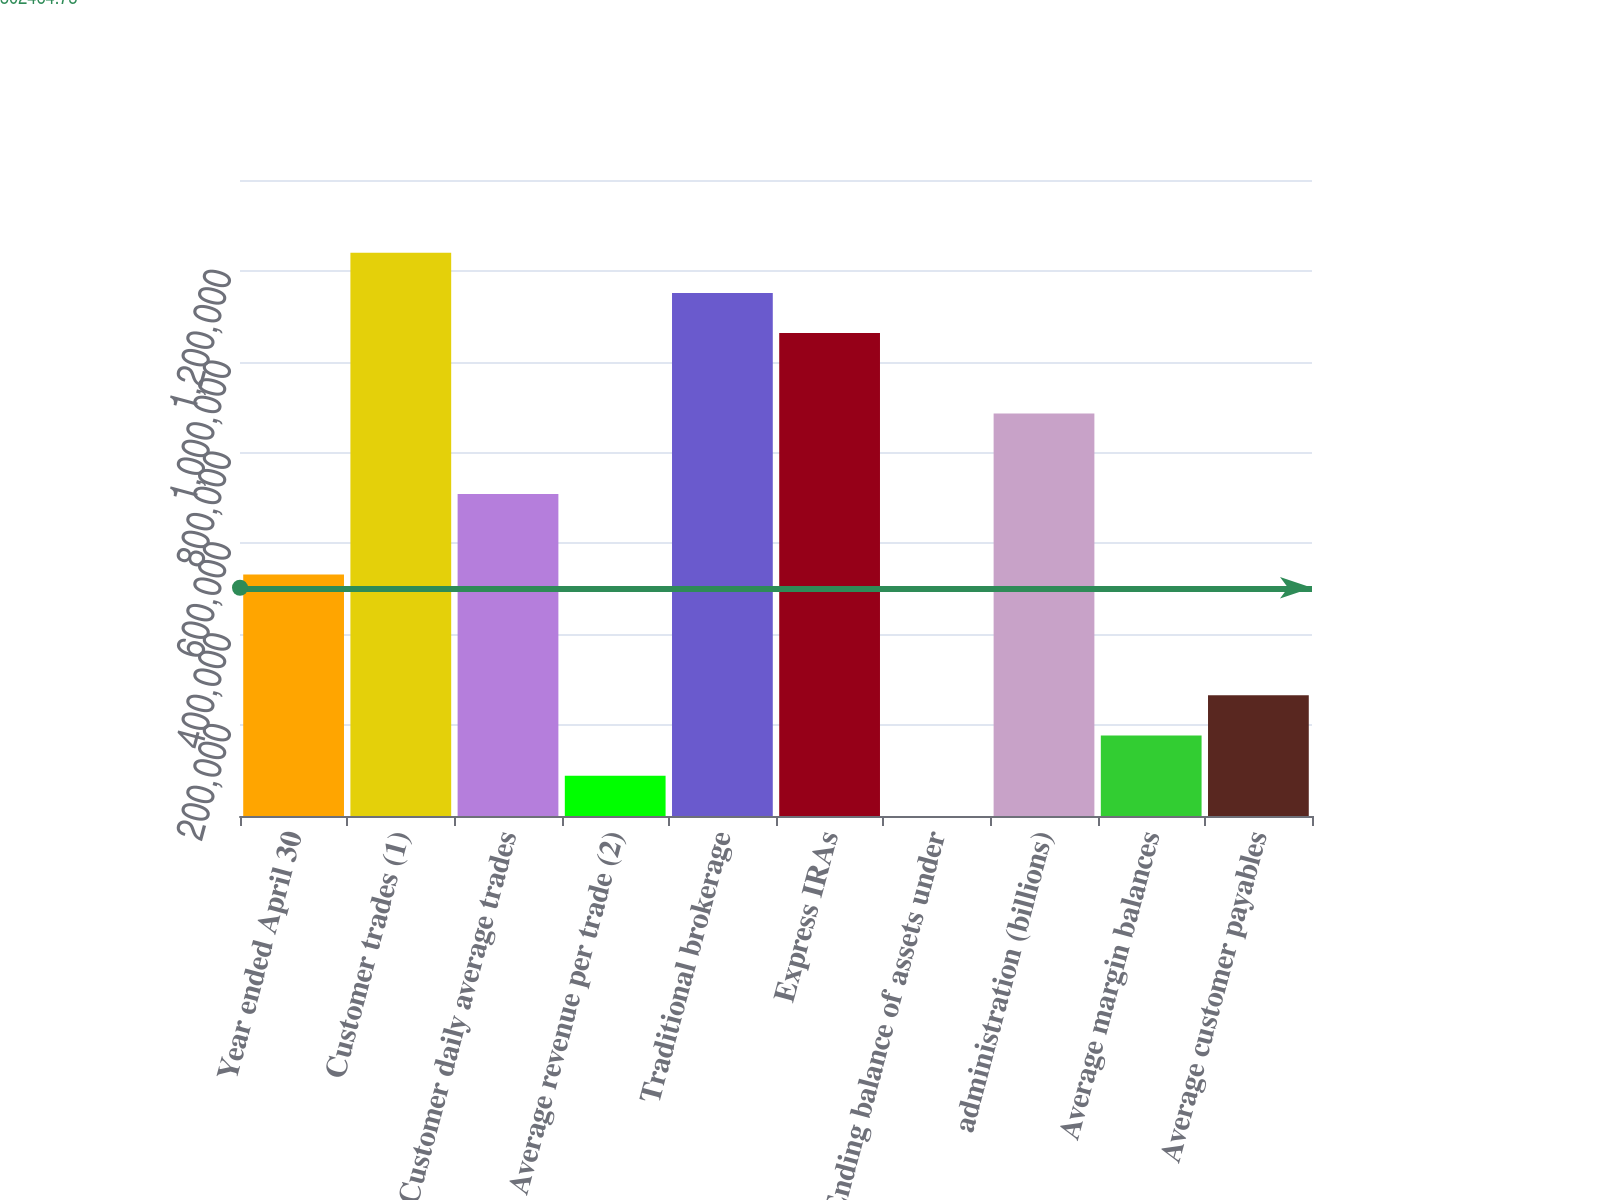Convert chart to OTSL. <chart><loc_0><loc_0><loc_500><loc_500><bar_chart><fcel>Year ended April 30<fcel>Customer trades (1)<fcel>Customer daily average trades<fcel>Average revenue per trade (2)<fcel>Traditional brokerage<fcel>Express IRAs<fcel>Ending balance of assets under<fcel>administration (billions)<fcel>Average margin balances<fcel>Average customer payables<nl><fcel>531489<fcel>1.2401e+06<fcel>708642<fcel>88604.6<fcel>1.15153e+06<fcel>1.06295e+06<fcel>27.8<fcel>885796<fcel>177181<fcel>265758<nl></chart> 